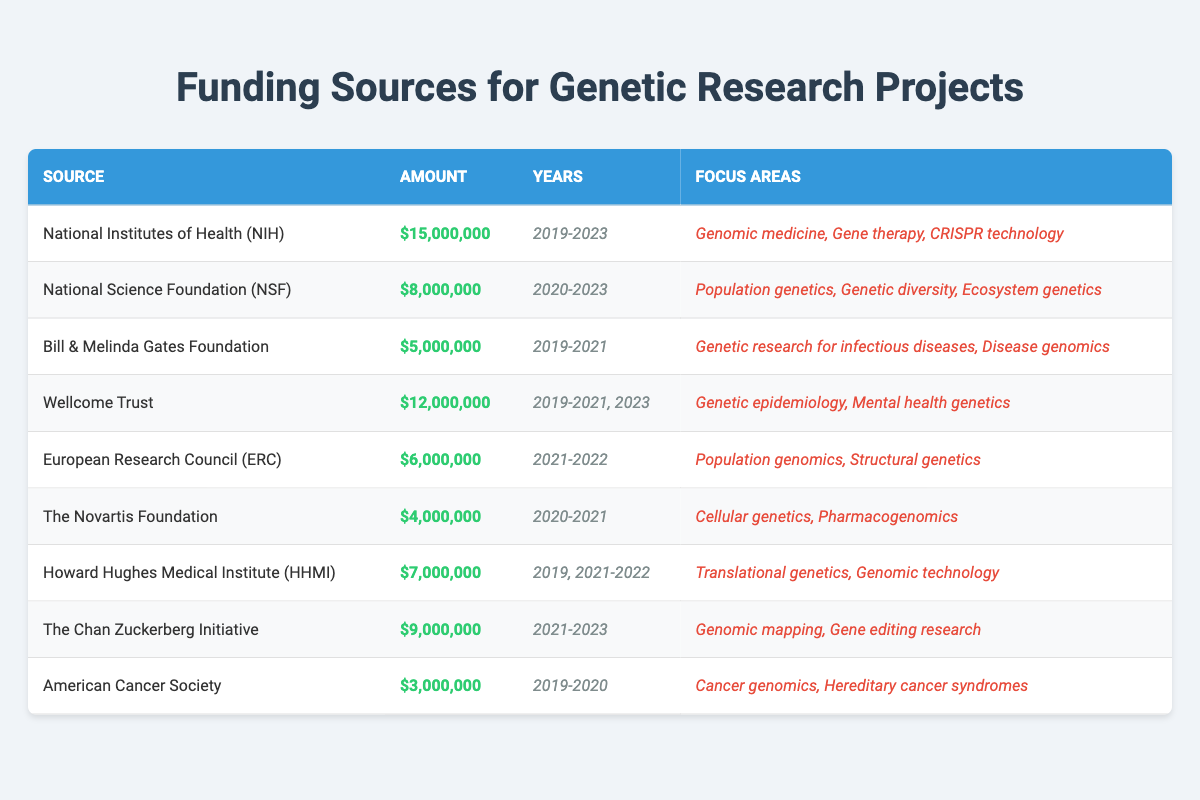What is the total funding amount from the National Institutes of Health (NIH)? The table shows that the NIH provided a total amount of $15,000,000 over the years listed.
Answer: $15,000,000 Which funding source contributed the least amount? According to the table, the American Cancer Society contributed the least, with $3,000,000.
Answer: $3,000,000 How many unique years did the National Science Foundation (NSF) provide funding? The NSF funded research in four unique years: 2020, 2021, 2022, and 2023.
Answer: 4 Did the Bill & Melinda Gates Foundation fund research in 2022? The table indicates that the Gates Foundation did not provide funding in 2022, as their years of funding are only 2019, 2020, and 2021.
Answer: No What is the total funding amount from the Wellcome Trust and the Chan Zuckerberg Initiative combined? To find the combined total, add Wellcome Trust's $12,000,000 and Chan Zuckerberg Initiative's $9,000,000: $12,000,000 + $9,000,000 = $21,000,000.
Answer: $21,000,000 How many focus areas are listed for the Howard Hughes Medical Institute (HHMI)? The HHMI has two focus areas listed in the table: "Translational genetics" and "Genomic technology."
Answer: 2 What years did the Novartis Foundation provide funding? The Novartis Foundation provided funding in two years: 2020 and 2021.
Answer: 2020, 2021 Which funding source has the highest amount of funding? The National Institutes of Health (NIH) has the highest funding amount at $15,000,000.
Answer: NIH What is the average funding amount for the European Research Council (ERC) over its funding years? The ERC provided a total of $6,000,000 over two years (2021 and 2022). To find the average: $6,000,000 / 2 = $3,000,000.
Answer: $3,000,000 Did the American Cancer Society contribute funding in 2021? The data shows that the American Cancer Society only contributed funding in the years 2019 and 2020, so they did not fund in 2021.
Answer: No 